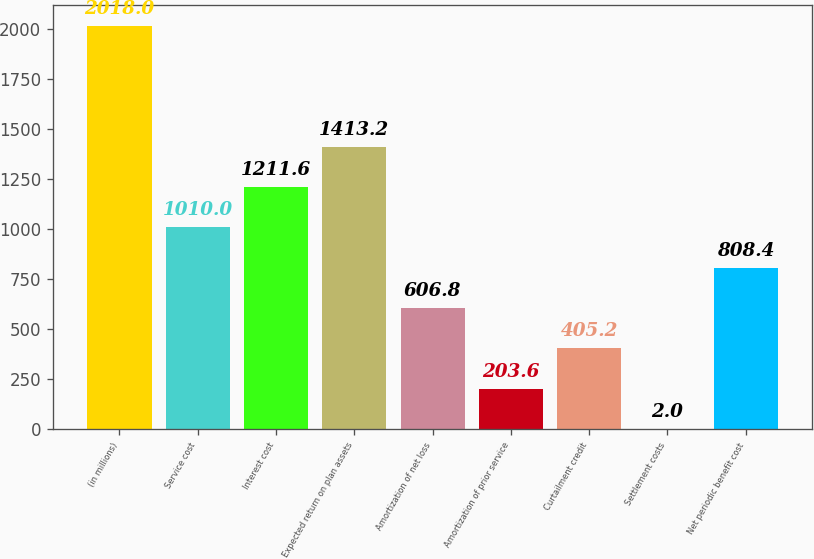Convert chart. <chart><loc_0><loc_0><loc_500><loc_500><bar_chart><fcel>(in millions)<fcel>Service cost<fcel>Interest cost<fcel>Expected return on plan assets<fcel>Amortization of net loss<fcel>Amortization of prior service<fcel>Curtailment credit<fcel>Settlement costs<fcel>Net periodic benefit cost<nl><fcel>2018<fcel>1010<fcel>1211.6<fcel>1413.2<fcel>606.8<fcel>203.6<fcel>405.2<fcel>2<fcel>808.4<nl></chart> 